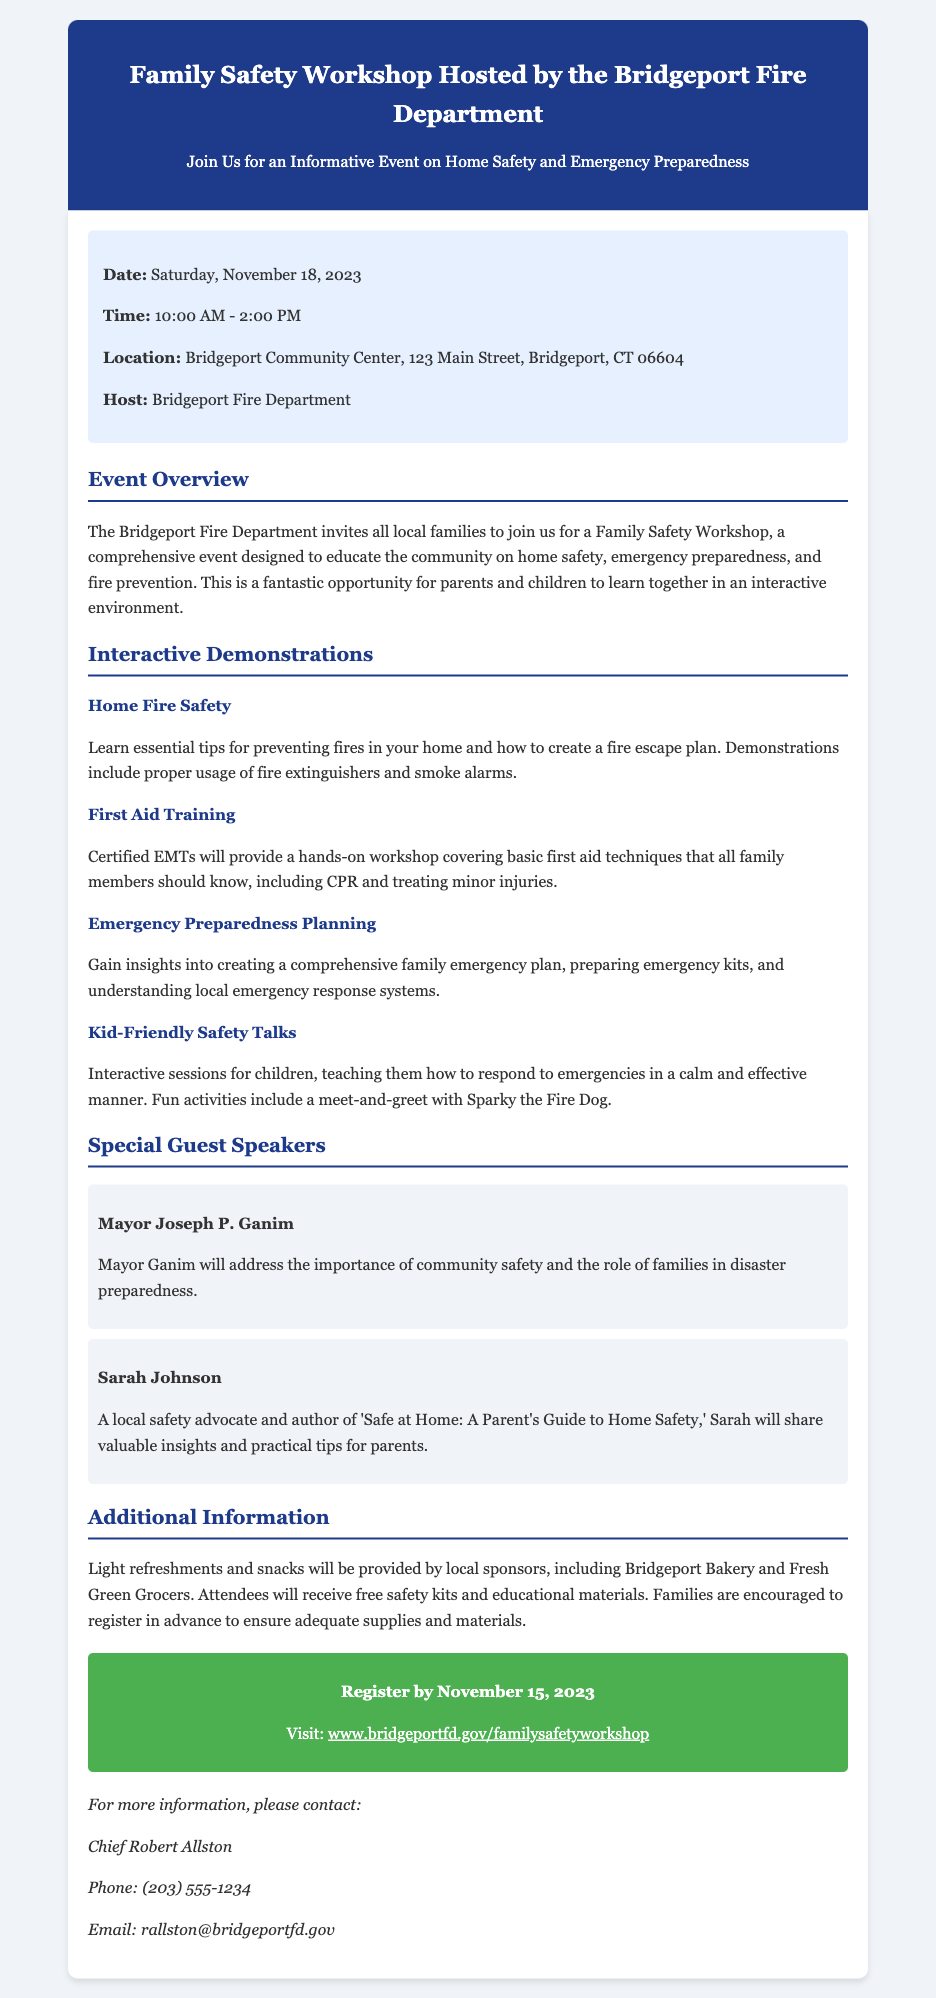What date is the workshop? The date of the workshop is explicitly stated in the event details section of the document.
Answer: Saturday, November 18, 2023 What is the location of the event? The document provides the address of the event in the event details section.
Answer: Bridgeport Community Center, 123 Main Street, Bridgeport, CT 06604 Who is hosting the workshop? The host is mentioned in the event details section of the document.
Answer: Bridgeport Fire Department What is one of the interactive demonstrations at the workshop? The document lists several demonstrations under the interactive demonstrations section, presenting an example.
Answer: Home Fire Safety Who will speak at the event? The document includes names of special guest speakers, highlighting their importance to the workshop.
Answer: Mayor Joseph P. Ganim What should families do to ensure adequate supplies for the workshop? The document indicates a specific action for families related to preparation for participation.
Answer: Register in advance What time does the workshop start? The start time is specified in the event details section, indicating when the workshop will begin.
Answer: 10:00 AM What will be provided to attendees at the workshop? The document mentions amenities offered to participants in the additional information section.
Answer: Light refreshments and snacks 